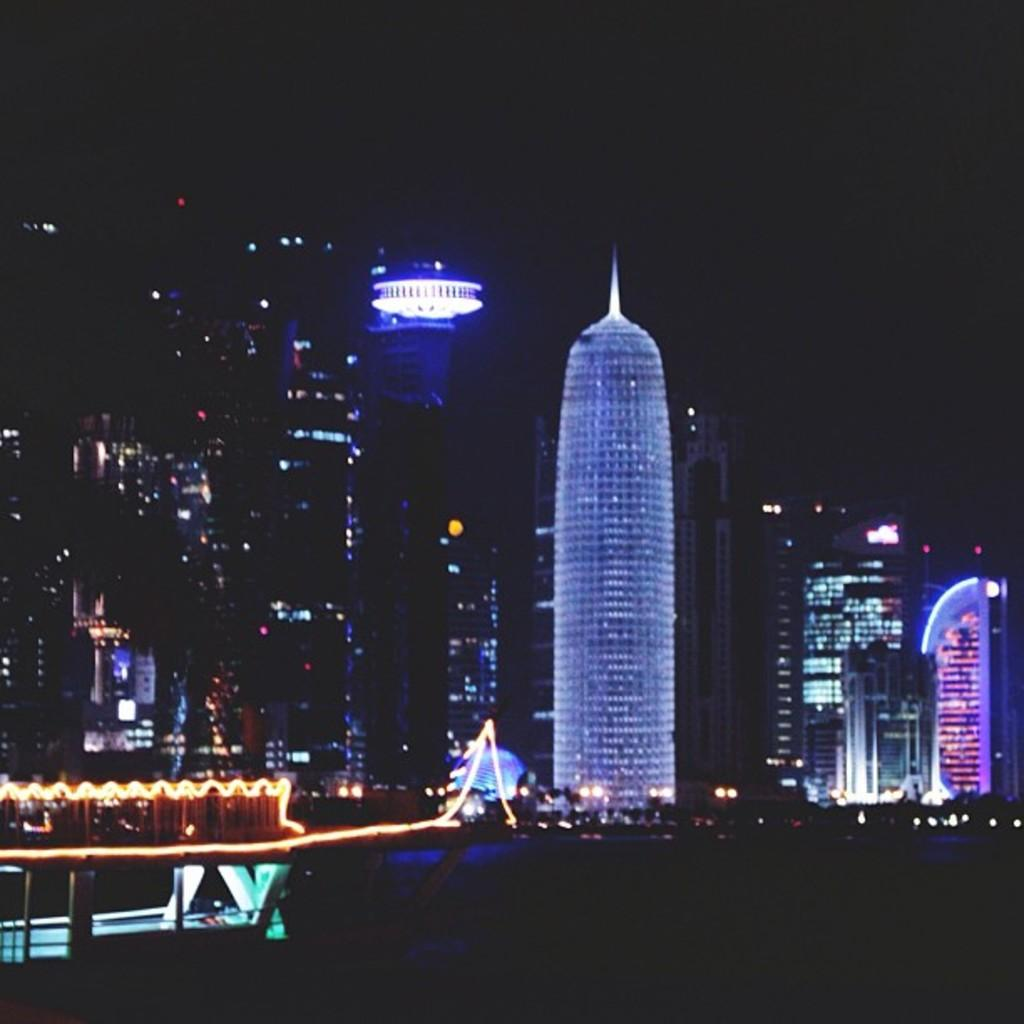What type of structures are visible in the image? There are buildings and towers in the image. What amusement park ride can be seen on the left side of the image? There is a roller coaster on the left side of the image. What is the lighting condition in the image? The image is clicked in the dark. What color is the top part of the image? The top of the image is black in color. How many bears are visible in the image? There are no bears present in the image. What thought is being expressed by the roller coaster in the image? The roller coaster is an inanimate object and cannot express thoughts. 